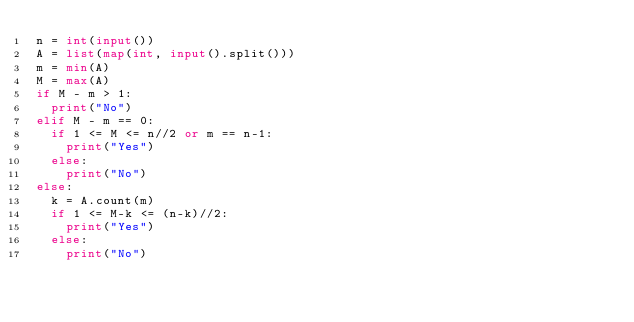<code> <loc_0><loc_0><loc_500><loc_500><_Python_>n = int(input())
A = list(map(int, input().split()))
m = min(A)
M = max(A)
if M - m > 1:
  print("No")
elif M - m == 0:
  if 1 <= M <= n//2 or m == n-1:
    print("Yes")
  else:
    print("No")
else:
  k = A.count(m)
  if 1 <= M-k <= (n-k)//2:
    print("Yes")
  else:
    print("No")</code> 